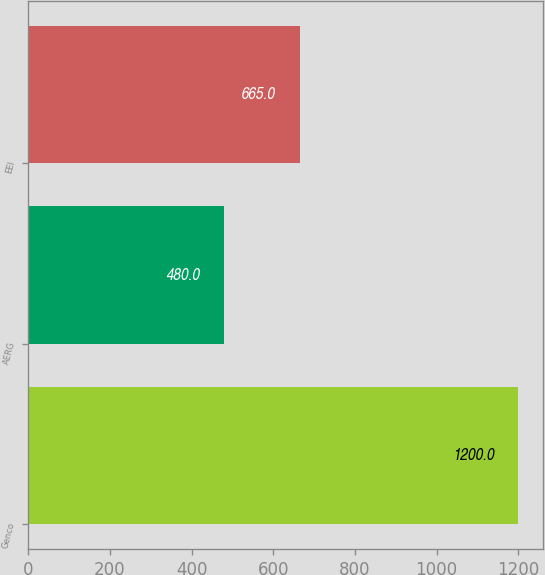<chart> <loc_0><loc_0><loc_500><loc_500><bar_chart><fcel>Genco<fcel>AERG<fcel>EEI<nl><fcel>1200<fcel>480<fcel>665<nl></chart> 